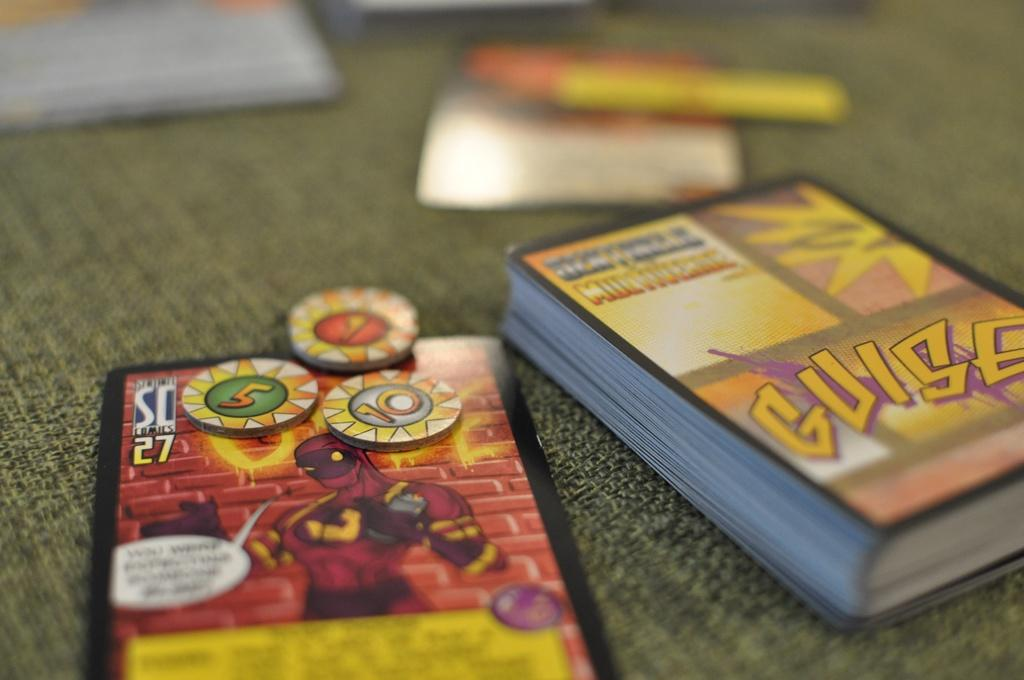<image>
Create a compact narrative representing the image presented. A stack of Yugioh cards with toy coins on top. 